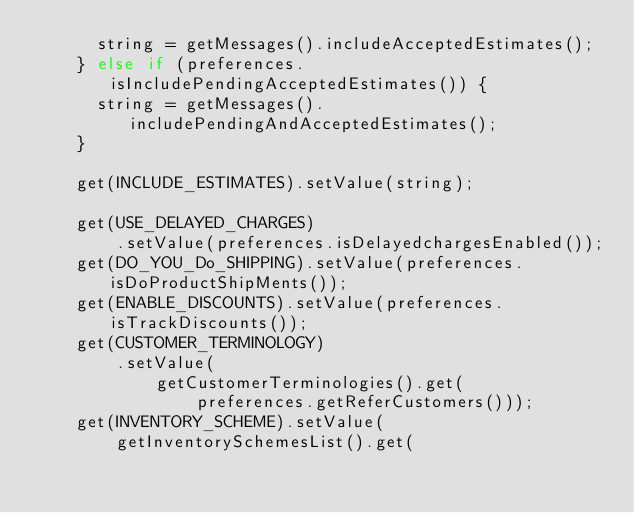Convert code to text. <code><loc_0><loc_0><loc_500><loc_500><_Java_>			string = getMessages().includeAcceptedEstimates();
		} else if (preferences.isIncludePendingAcceptedEstimates()) {
			string = getMessages().includePendingAndAcceptedEstimates();
		}

		get(INCLUDE_ESTIMATES).setValue(string);

		get(USE_DELAYED_CHARGES)
				.setValue(preferences.isDelayedchargesEnabled());
		get(DO_YOU_Do_SHIPPING).setValue(preferences.isDoProductShipMents());
		get(ENABLE_DISCOUNTS).setValue(preferences.isTrackDiscounts());
		get(CUSTOMER_TERMINOLOGY)
				.setValue(
						getCustomerTerminologies().get(
								preferences.getReferCustomers()));
		get(INVENTORY_SCHEME).setValue(
				getInventorySchemesList().get(</code> 